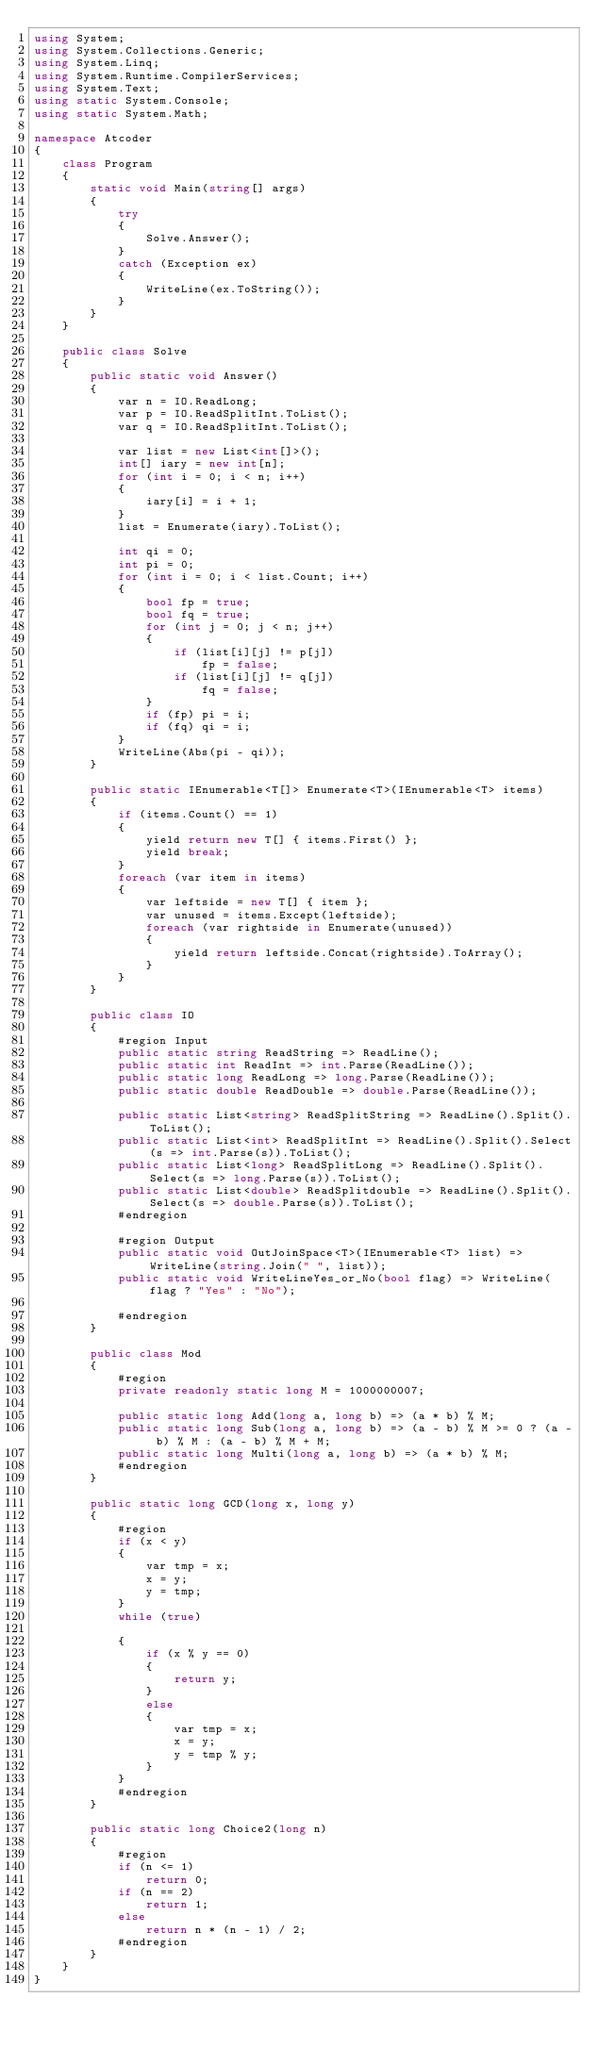Convert code to text. <code><loc_0><loc_0><loc_500><loc_500><_C#_>using System;
using System.Collections.Generic;
using System.Linq;
using System.Runtime.CompilerServices;
using System.Text;
using static System.Console;
using static System.Math;

namespace Atcoder
{
    class Program
    {
        static void Main(string[] args)
        {
            try
            {
                Solve.Answer();
            }
            catch (Exception ex)
            {
                WriteLine(ex.ToString());
            }
        }
    }

    public class Solve
    {
        public static void Answer()
        {
            var n = IO.ReadLong;
            var p = IO.ReadSplitInt.ToList();
            var q = IO.ReadSplitInt.ToList();

            var list = new List<int[]>();
            int[] iary = new int[n];
            for (int i = 0; i < n; i++)
            {
                iary[i] = i + 1;
            }
            list = Enumerate(iary).ToList();

            int qi = 0;
            int pi = 0;
            for (int i = 0; i < list.Count; i++)
            {
                bool fp = true;
                bool fq = true;
                for (int j = 0; j < n; j++)
                {
                    if (list[i][j] != p[j])
                        fp = false;
                    if (list[i][j] != q[j])
                        fq = false;
                }
                if (fp) pi = i;
                if (fq) qi = i;
            }
            WriteLine(Abs(pi - qi));
        }

        public static IEnumerable<T[]> Enumerate<T>(IEnumerable<T> items)
        {
            if (items.Count() == 1)
            {
                yield return new T[] { items.First() };
                yield break;
            }
            foreach (var item in items)
            {
                var leftside = new T[] { item };
                var unused = items.Except(leftside);
                foreach (var rightside in Enumerate(unused))
                {
                    yield return leftside.Concat(rightside).ToArray();
                }
            }
        }

        public class IO
        {
            #region Input
            public static string ReadString => ReadLine();
            public static int ReadInt => int.Parse(ReadLine());
            public static long ReadLong => long.Parse(ReadLine());
            public static double ReadDouble => double.Parse(ReadLine());

            public static List<string> ReadSplitString => ReadLine().Split().ToList();
            public static List<int> ReadSplitInt => ReadLine().Split().Select(s => int.Parse(s)).ToList();
            public static List<long> ReadSplitLong => ReadLine().Split().Select(s => long.Parse(s)).ToList();
            public static List<double> ReadSplitdouble => ReadLine().Split().Select(s => double.Parse(s)).ToList();
            #endregion

            #region Output
            public static void OutJoinSpace<T>(IEnumerable<T> list) => WriteLine(string.Join(" ", list));
            public static void WriteLineYes_or_No(bool flag) => WriteLine(flag ? "Yes" : "No");

            #endregion
        }

        public class Mod
        {
            #region
            private readonly static long M = 1000000007;

            public static long Add(long a, long b) => (a * b) % M;
            public static long Sub(long a, long b) => (a - b) % M >= 0 ? (a - b) % M : (a - b) % M + M;
            public static long Multi(long a, long b) => (a * b) % M;
            #endregion
        }

        public static long GCD(long x, long y)
        {
            #region
            if (x < y)
            {
                var tmp = x;
                x = y;
                y = tmp;
            }
            while (true)

            {
                if (x % y == 0)
                {
                    return y;
                }
                else
                {
                    var tmp = x;
                    x = y;
                    y = tmp % y;
                }
            }
            #endregion
        }

        public static long Choice2(long n)
        {
            #region
            if (n <= 1)
                return 0;
            if (n == 2)
                return 1;
            else
                return n * (n - 1) / 2;
            #endregion
        }
    }
}</code> 